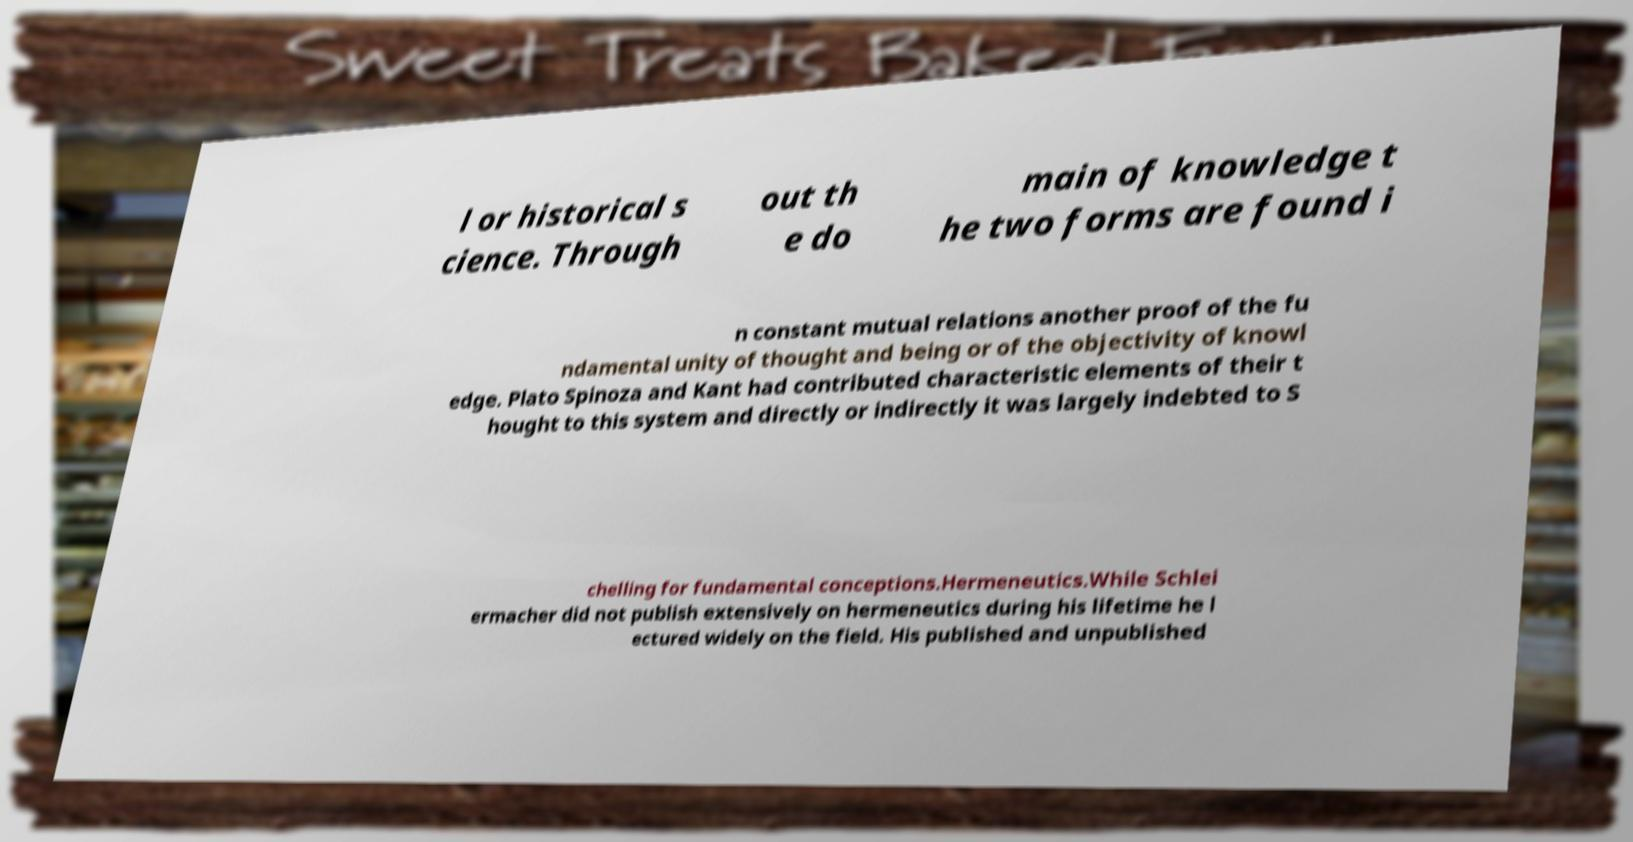Please read and relay the text visible in this image. What does it say? l or historical s cience. Through out th e do main of knowledge t he two forms are found i n constant mutual relations another proof of the fu ndamental unity of thought and being or of the objectivity of knowl edge. Plato Spinoza and Kant had contributed characteristic elements of their t hought to this system and directly or indirectly it was largely indebted to S chelling for fundamental conceptions.Hermeneutics.While Schlei ermacher did not publish extensively on hermeneutics during his lifetime he l ectured widely on the field. His published and unpublished 